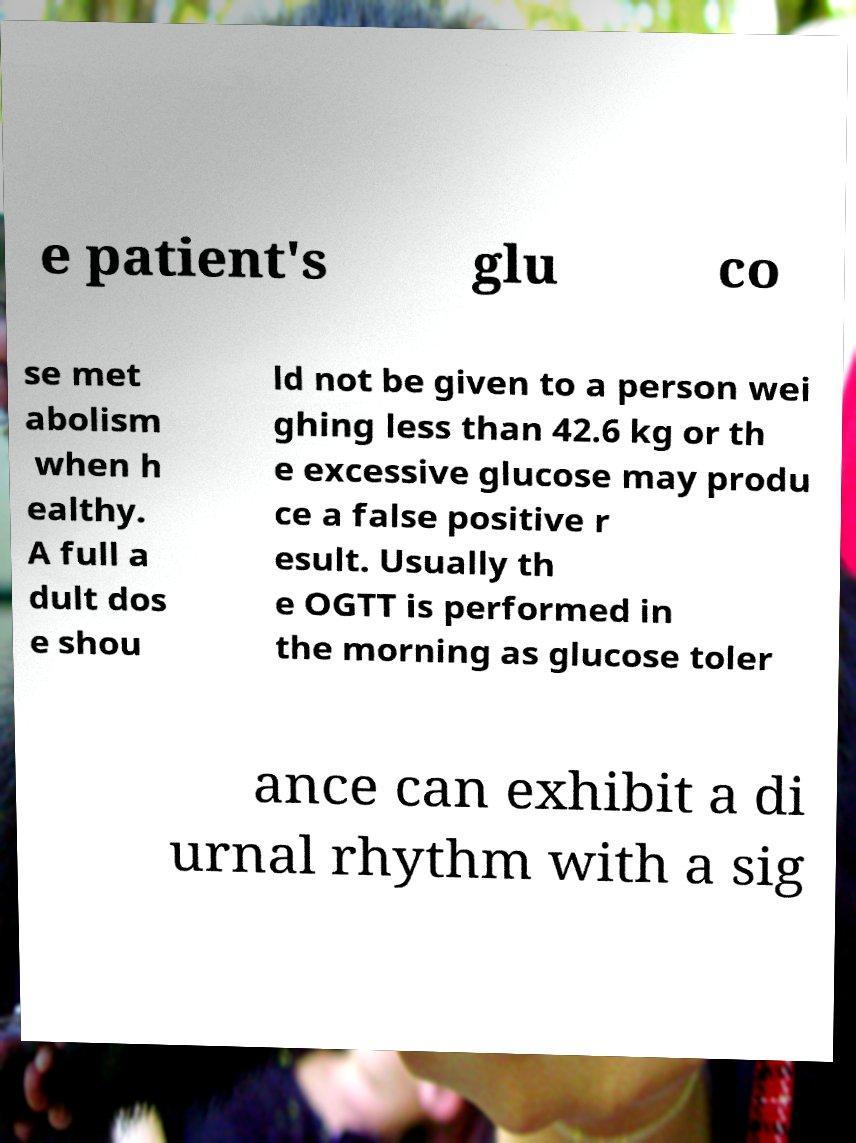Could you extract and type out the text from this image? e patient's glu co se met abolism when h ealthy. A full a dult dos e shou ld not be given to a person wei ghing less than 42.6 kg or th e excessive glucose may produ ce a false positive r esult. Usually th e OGTT is performed in the morning as glucose toler ance can exhibit a di urnal rhythm with a sig 